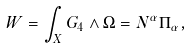Convert formula to latex. <formula><loc_0><loc_0><loc_500><loc_500>W = \int _ { X } G _ { 4 } \wedge \Omega = N ^ { \alpha } \Pi _ { \alpha } ,</formula> 